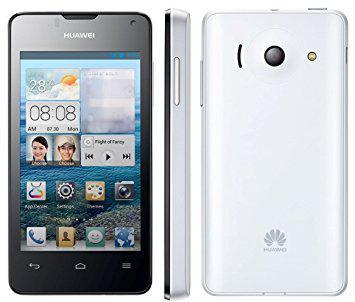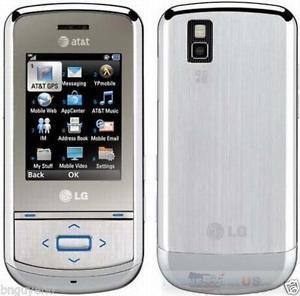The first image is the image on the left, the second image is the image on the right. Analyze the images presented: Is the assertion "A phone's side profile is in the right image." valid? Answer yes or no. No. The first image is the image on the left, the second image is the image on the right. Assess this claim about the two images: "There are more phones in the image on the right, and only a single phone in the image on the left.". Correct or not? Answer yes or no. No. 